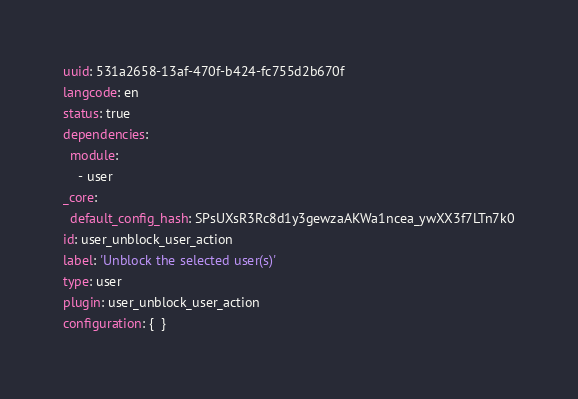<code> <loc_0><loc_0><loc_500><loc_500><_YAML_>uuid: 531a2658-13af-470f-b424-fc755d2b670f
langcode: en
status: true
dependencies:
  module:
    - user
_core:
  default_config_hash: SPsUXsR3Rc8d1y3gewzaAKWa1ncea_ywXX3f7LTn7k0
id: user_unblock_user_action
label: 'Unblock the selected user(s)'
type: user
plugin: user_unblock_user_action
configuration: {  }
</code> 